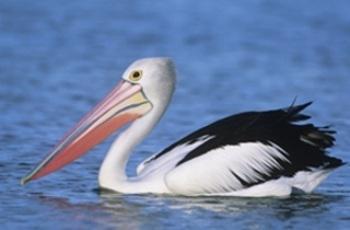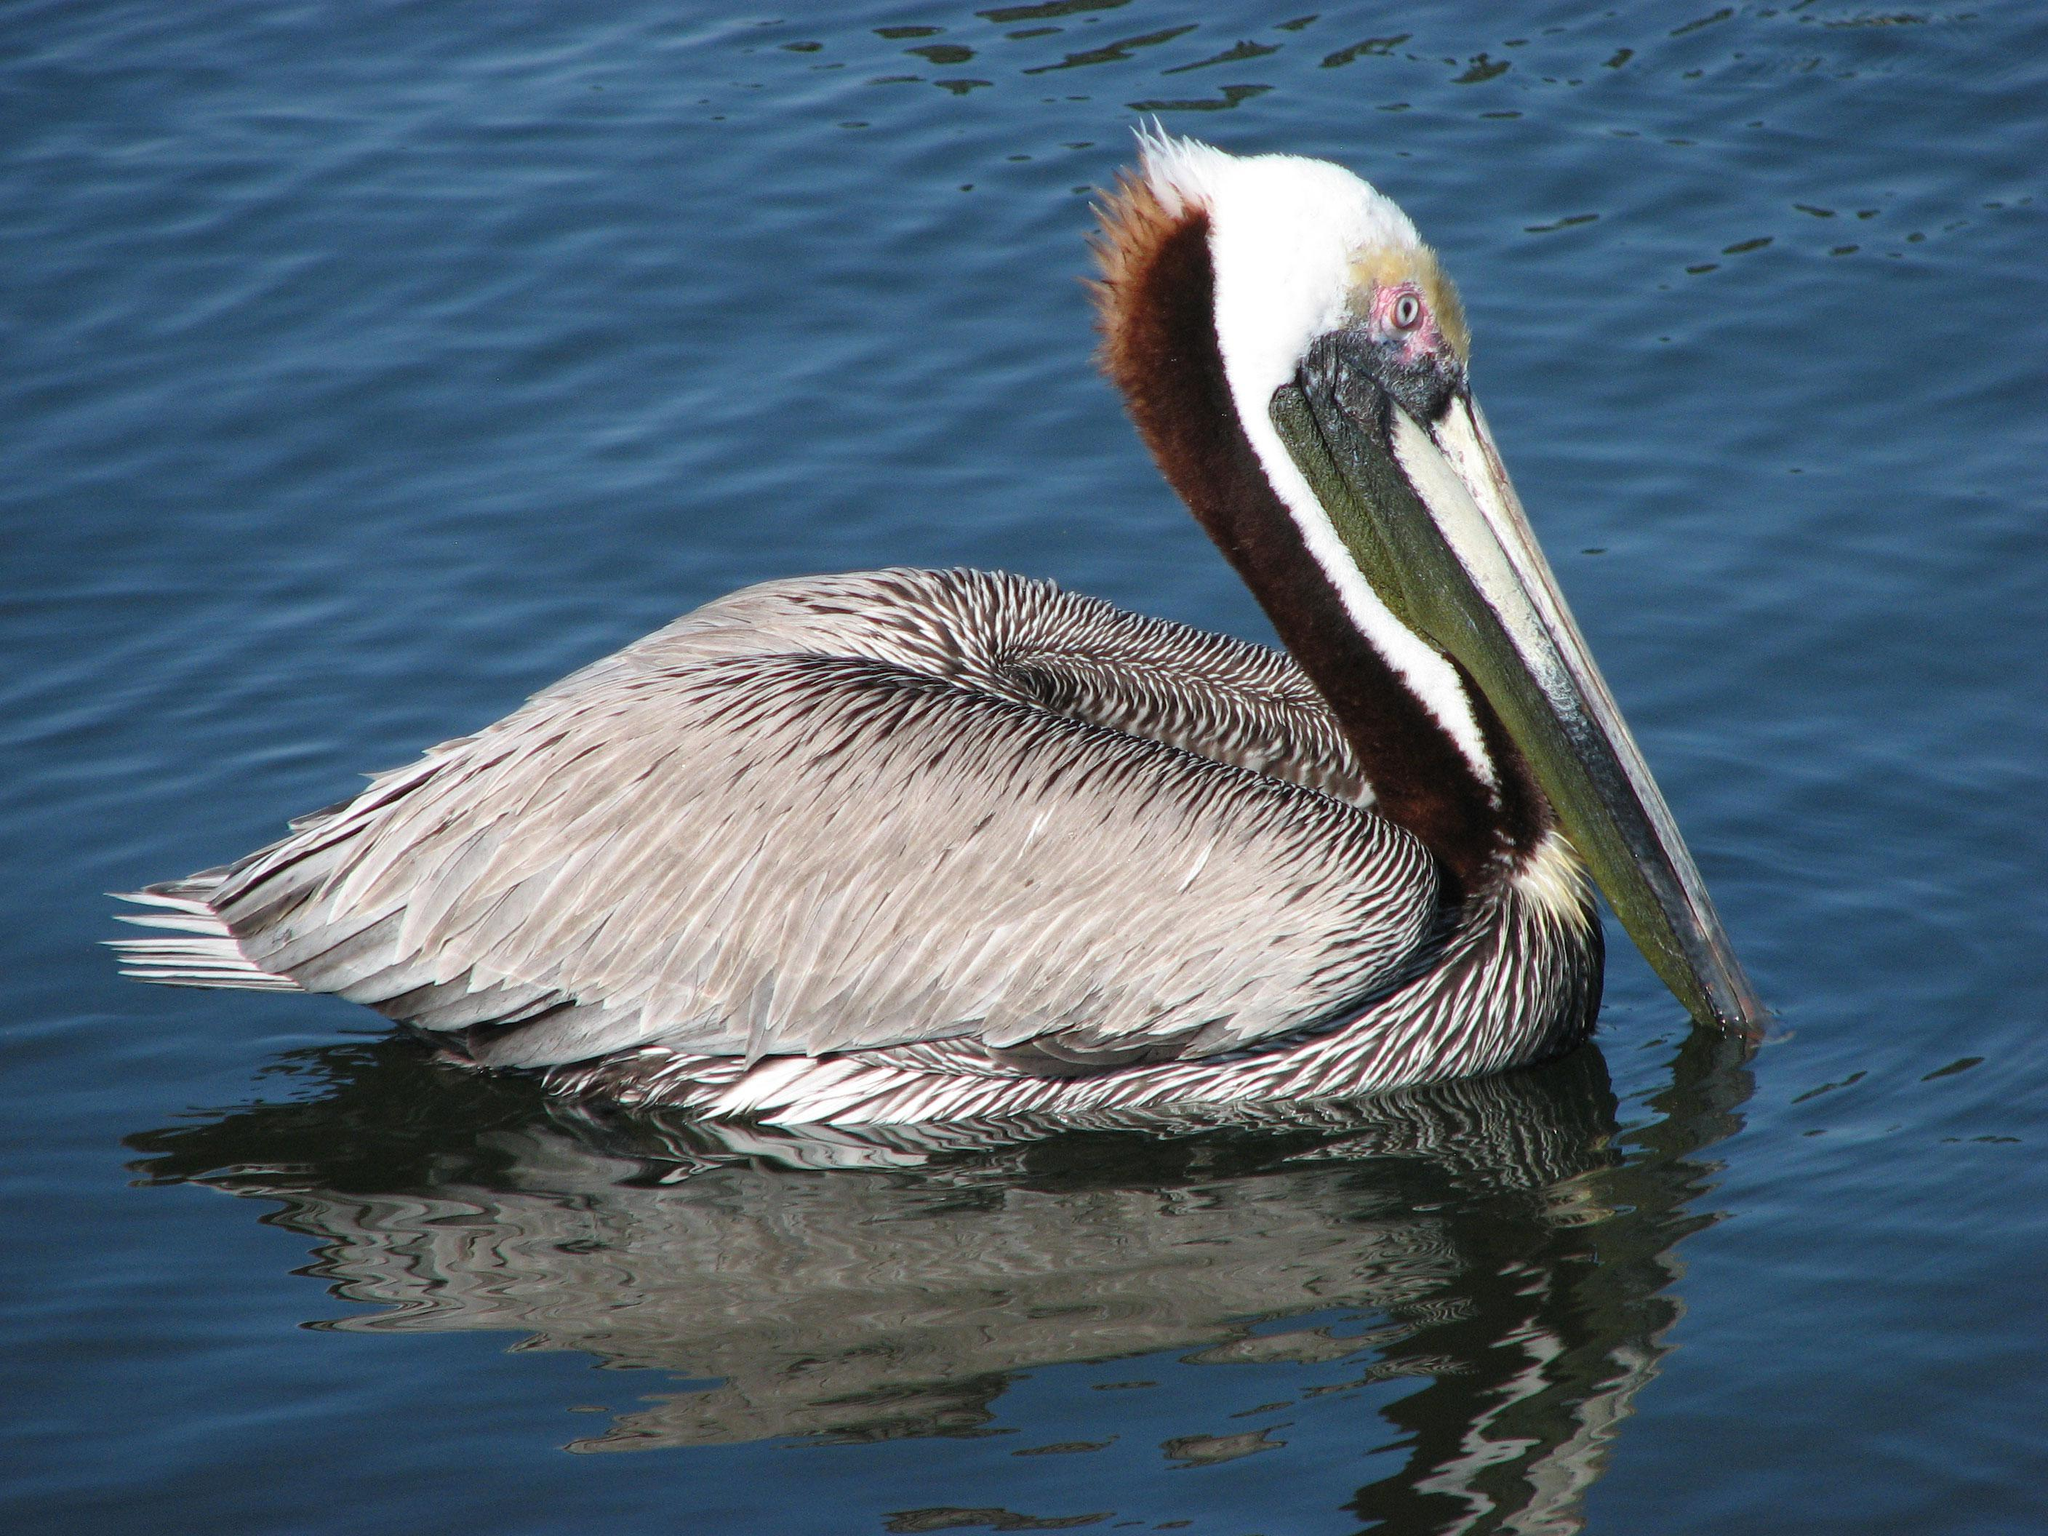The first image is the image on the left, the second image is the image on the right. Considering the images on both sides, is "At least one bird is standing, not swimming." valid? Answer yes or no. No. 